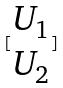<formula> <loc_0><loc_0><loc_500><loc_500>[ \begin{matrix} U _ { 1 } \\ U _ { 2 } \end{matrix} ]</formula> 